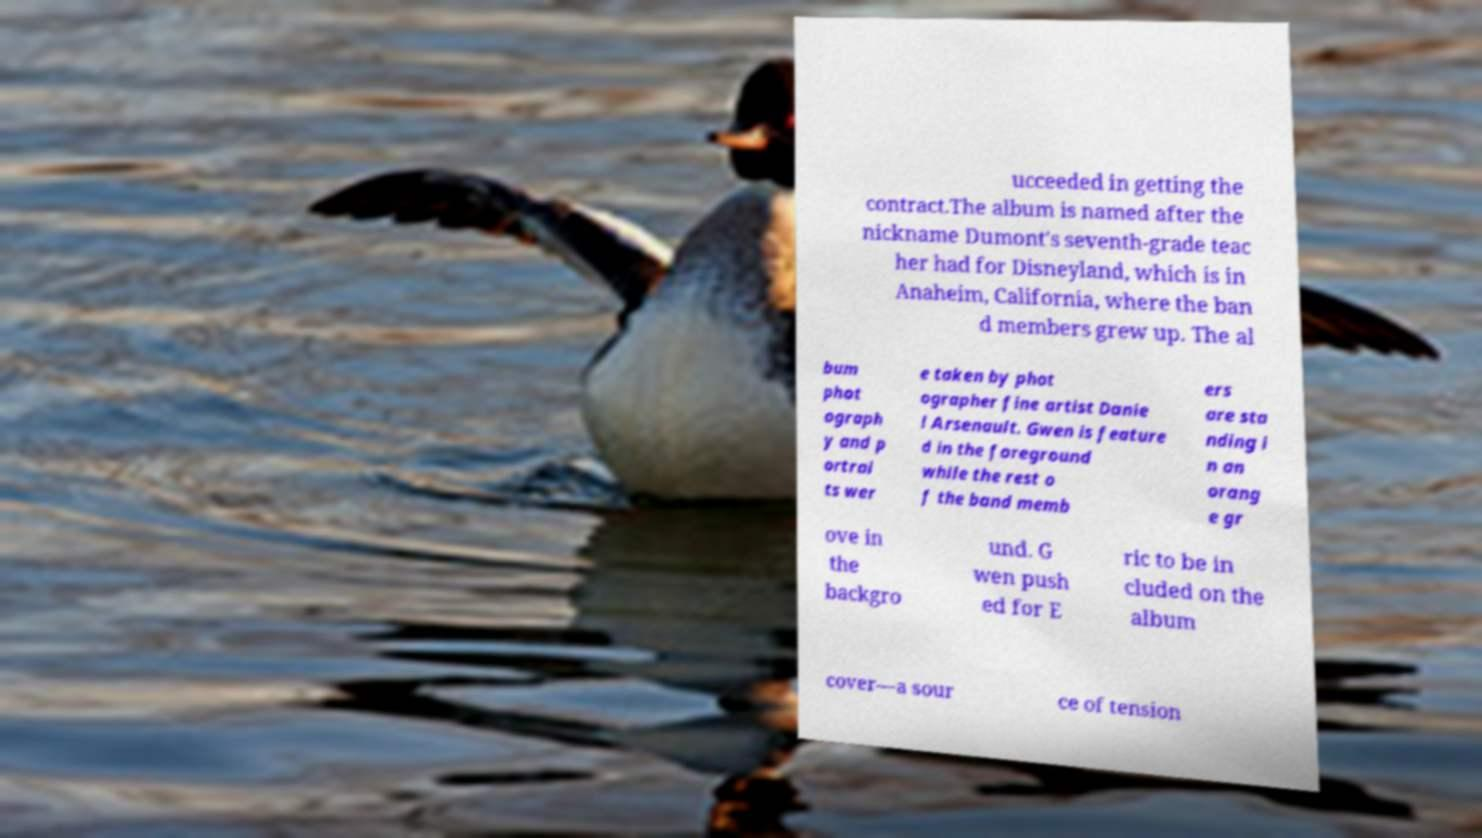Please identify and transcribe the text found in this image. ucceeded in getting the contract.The album is named after the nickname Dumont's seventh-grade teac her had for Disneyland, which is in Anaheim, California, where the ban d members grew up. The al bum phot ograph y and p ortrai ts wer e taken by phot ographer fine artist Danie l Arsenault. Gwen is feature d in the foreground while the rest o f the band memb ers are sta nding i n an orang e gr ove in the backgro und. G wen push ed for E ric to be in cluded on the album cover—a sour ce of tension 